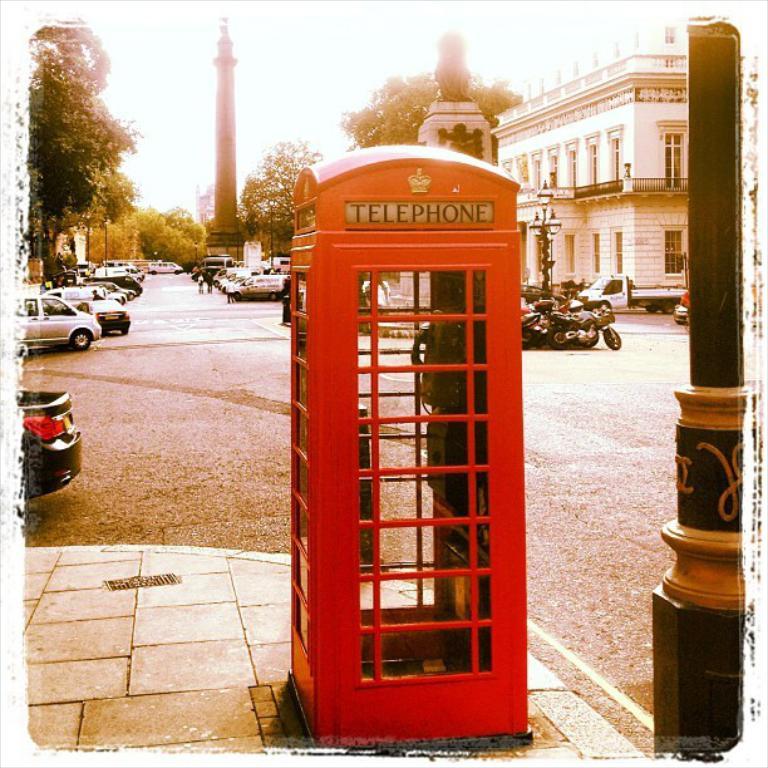What type of booth is this?
Your answer should be very brief. Telephone. 